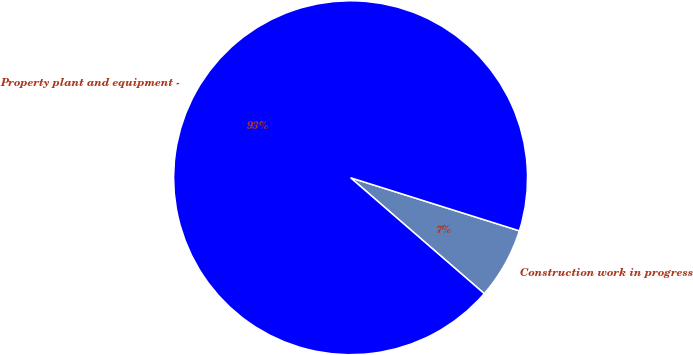Convert chart to OTSL. <chart><loc_0><loc_0><loc_500><loc_500><pie_chart><fcel>Construction work in progress<fcel>Property plant and equipment -<nl><fcel>6.52%<fcel>93.48%<nl></chart> 